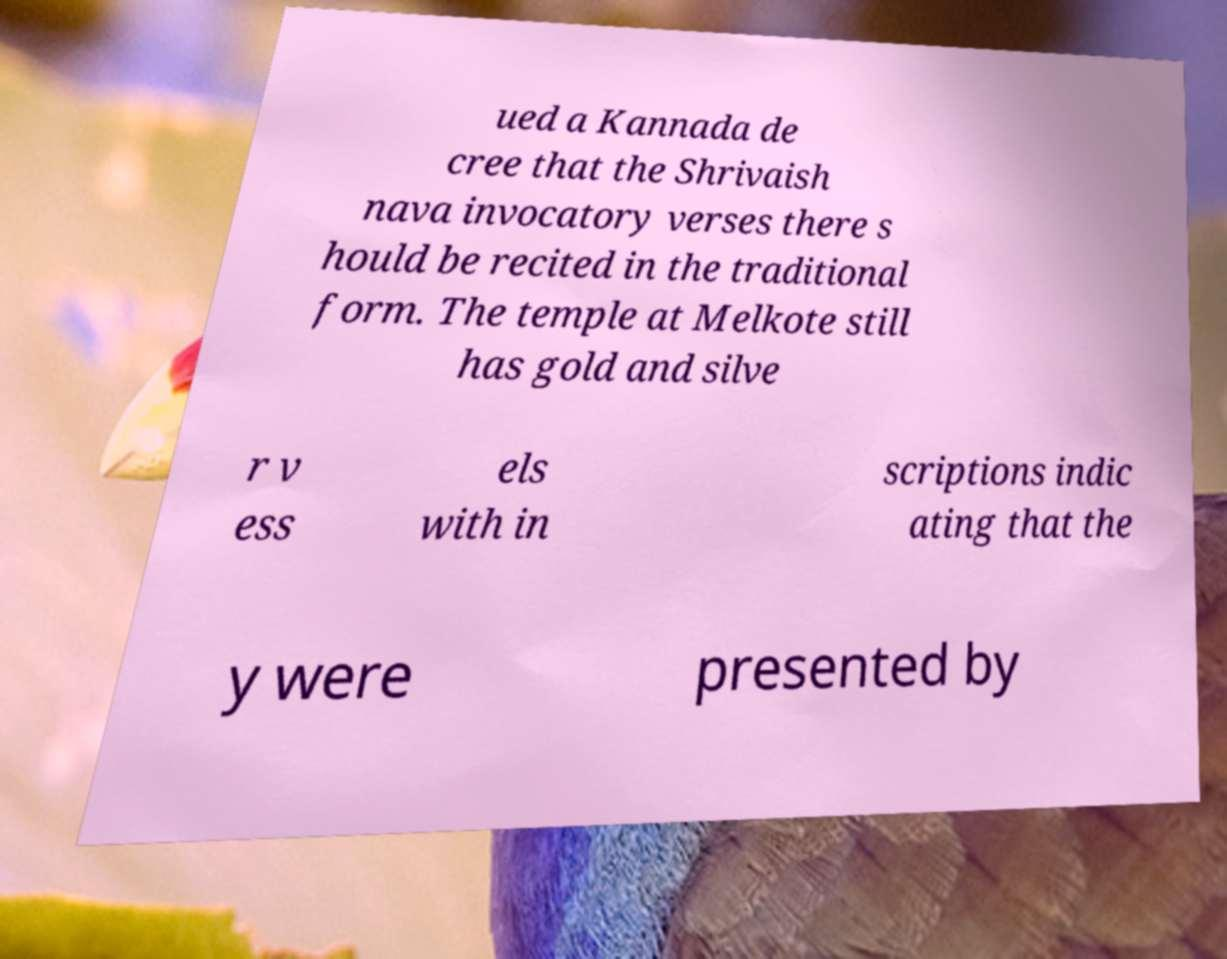Could you assist in decoding the text presented in this image and type it out clearly? ued a Kannada de cree that the Shrivaish nava invocatory verses there s hould be recited in the traditional form. The temple at Melkote still has gold and silve r v ess els with in scriptions indic ating that the y were presented by 